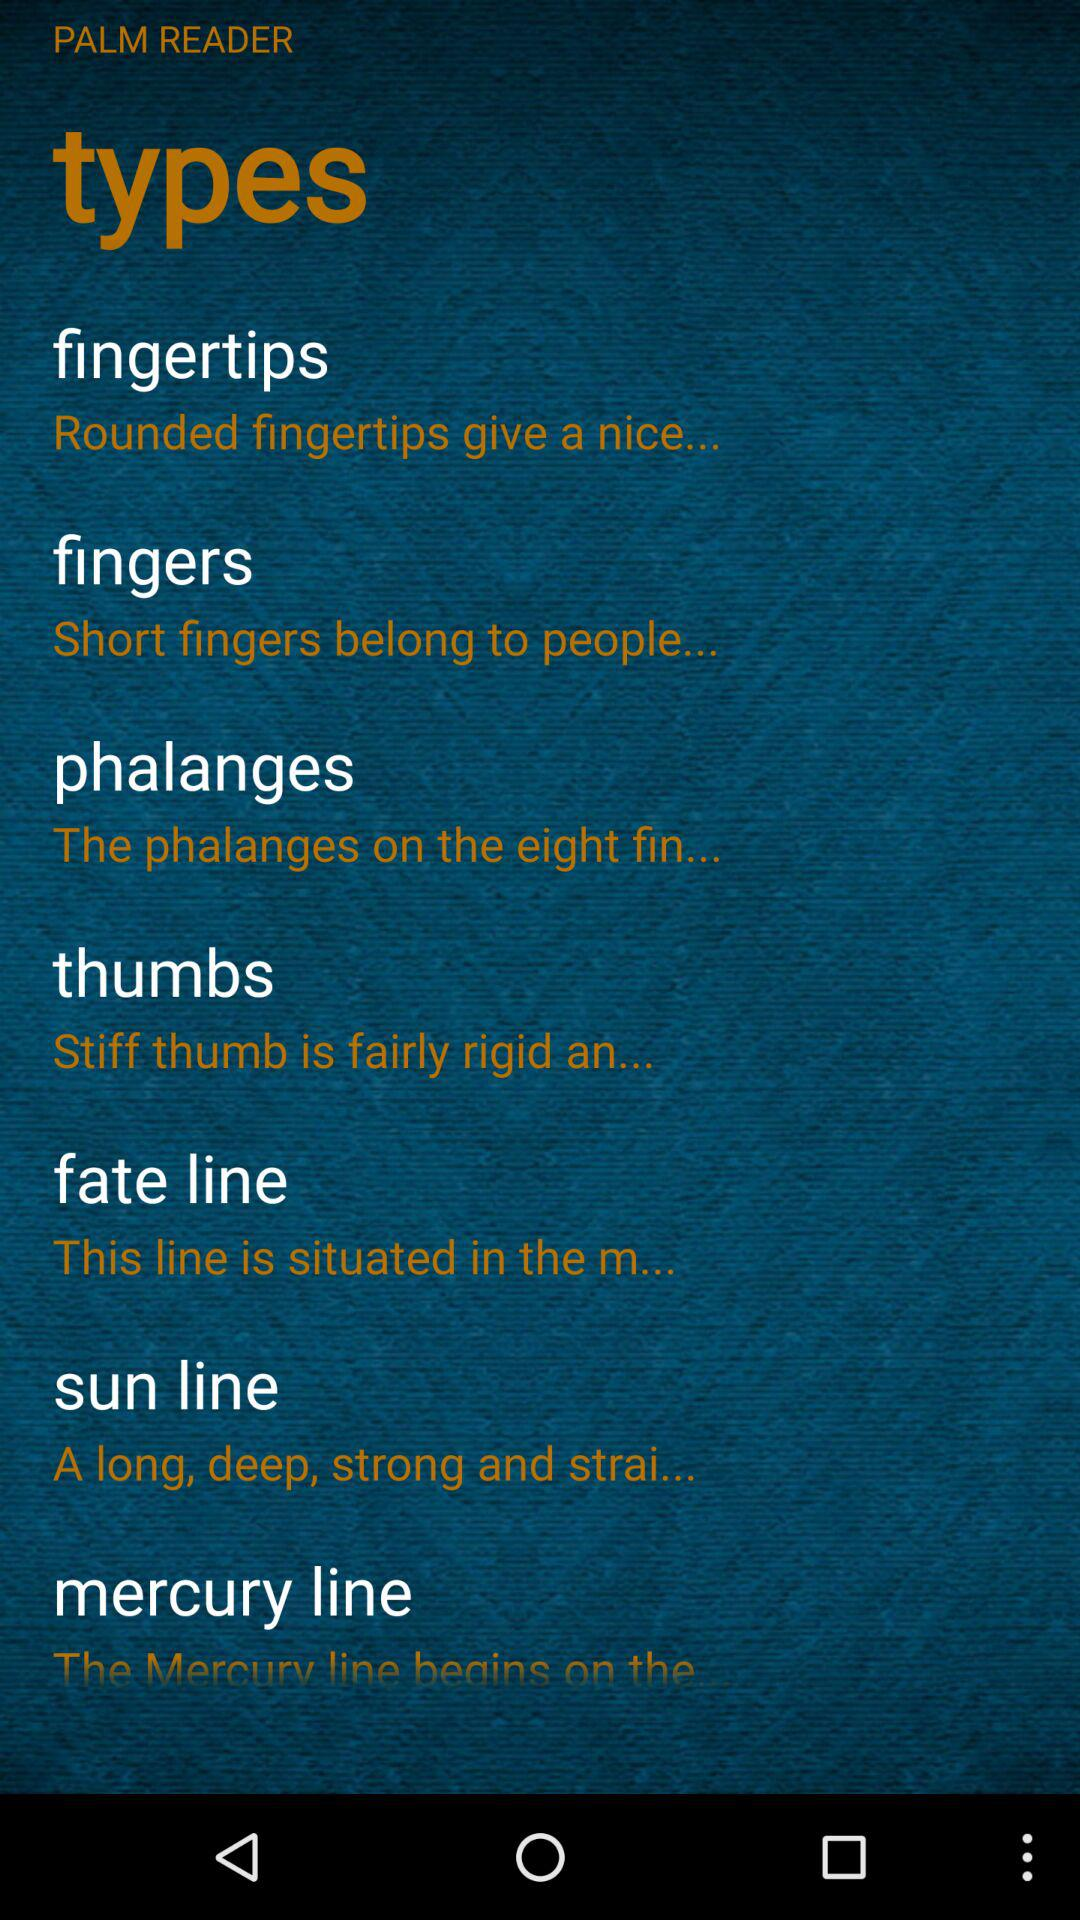What's the application name? The application name is "PALM READER". 